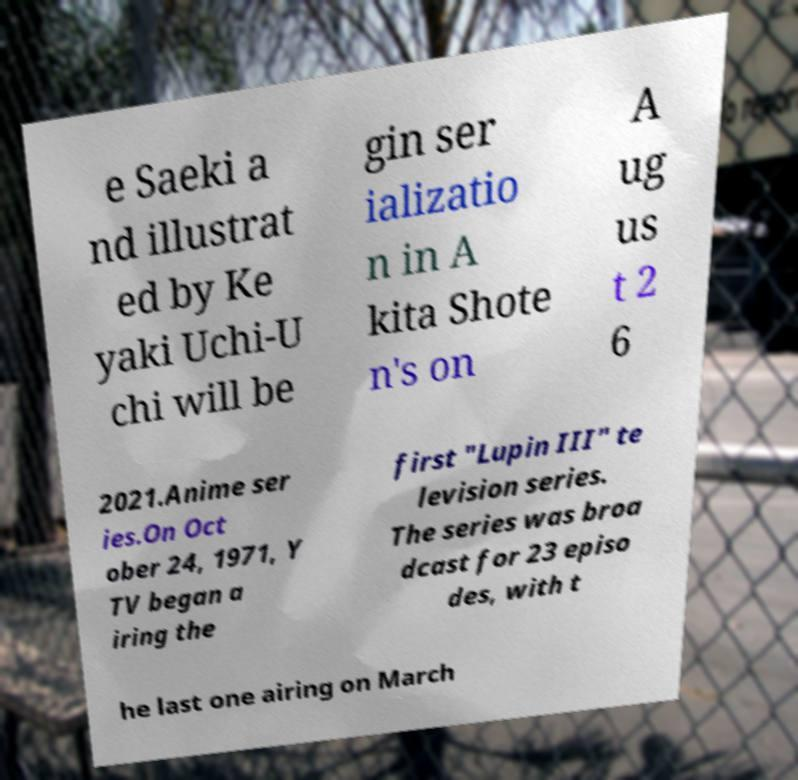Can you accurately transcribe the text from the provided image for me? e Saeki a nd illustrat ed by Ke yaki Uchi-U chi will be gin ser ializatio n in A kita Shote n's on A ug us t 2 6 2021.Anime ser ies.On Oct ober 24, 1971, Y TV began a iring the first "Lupin III" te levision series. The series was broa dcast for 23 episo des, with t he last one airing on March 